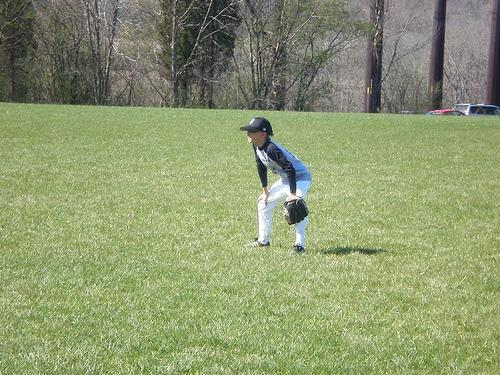What aspect of the game is being shown here?

Choices:
A) cheering
B) fielding
C) hitting
D) umpiring fielding 